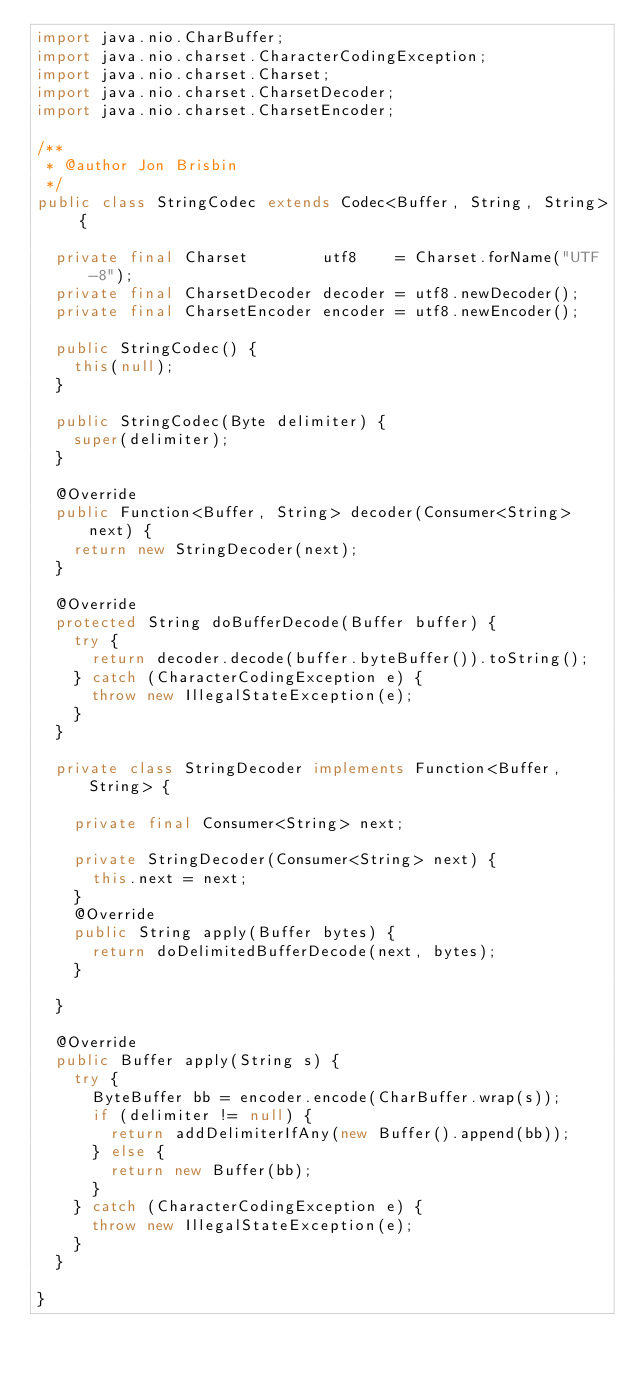Convert code to text. <code><loc_0><loc_0><loc_500><loc_500><_Java_>import java.nio.CharBuffer;
import java.nio.charset.CharacterCodingException;
import java.nio.charset.Charset;
import java.nio.charset.CharsetDecoder;
import java.nio.charset.CharsetEncoder;

/**
 * @author Jon Brisbin
 */
public class StringCodec extends Codec<Buffer, String, String> {

	private final Charset        utf8    = Charset.forName("UTF-8");
	private final CharsetDecoder decoder = utf8.newDecoder();
	private final CharsetEncoder encoder = utf8.newEncoder();

	public StringCodec() {
		this(null);
	}

	public StringCodec(Byte delimiter) {
		super(delimiter);
	}

	@Override
	public Function<Buffer, String> decoder(Consumer<String> next) {
		return new StringDecoder(next);
	}

	@Override
	protected String doBufferDecode(Buffer buffer) {
		try {
			return decoder.decode(buffer.byteBuffer()).toString();
		} catch (CharacterCodingException e) {
			throw new IllegalStateException(e);
		}
	}

	private class StringDecoder implements Function<Buffer, String> {

		private final Consumer<String> next;

		private StringDecoder(Consumer<String> next) {
			this.next = next;
		}
		@Override
		public String apply(Buffer bytes) {
			return doDelimitedBufferDecode(next, bytes);
		}

	}

	@Override
	public Buffer apply(String s) {
		try {
			ByteBuffer bb = encoder.encode(CharBuffer.wrap(s));
			if (delimiter != null) {
				return addDelimiterIfAny(new Buffer().append(bb));
			} else {
				return new Buffer(bb);
			}
		} catch (CharacterCodingException e) {
			throw new IllegalStateException(e);
		}
	}

}
</code> 